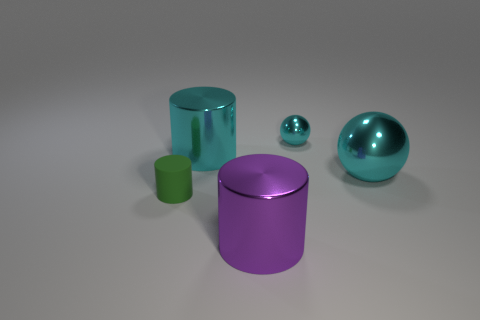Do the tiny matte thing and the tiny ball have the same color?
Your response must be concise. No. What is the material of the ball that is the same color as the small metal object?
Offer a terse response. Metal. Is the number of big metal balls in front of the tiny cylinder less than the number of cyan shiny balls to the right of the tiny metallic object?
Keep it short and to the point. Yes. Is the material of the small sphere the same as the big purple thing?
Give a very brief answer. Yes. What size is the cyan thing that is both in front of the tiny cyan metallic thing and right of the big cyan cylinder?
Provide a succinct answer. Large. What is the shape of the purple metal thing that is the same size as the cyan metallic cylinder?
Make the answer very short. Cylinder. What is the small green cylinder on the left side of the cyan metallic sphere that is behind the cyan object that is to the left of the big purple metal thing made of?
Provide a short and direct response. Rubber. There is a cyan metal thing to the left of the tiny ball; is its shape the same as the shiny thing in front of the small green rubber cylinder?
Offer a very short reply. Yes. What number of other objects are the same material as the small green thing?
Offer a very short reply. 0. Does the large object in front of the small green matte cylinder have the same material as the large object that is on the right side of the purple shiny cylinder?
Keep it short and to the point. Yes. 